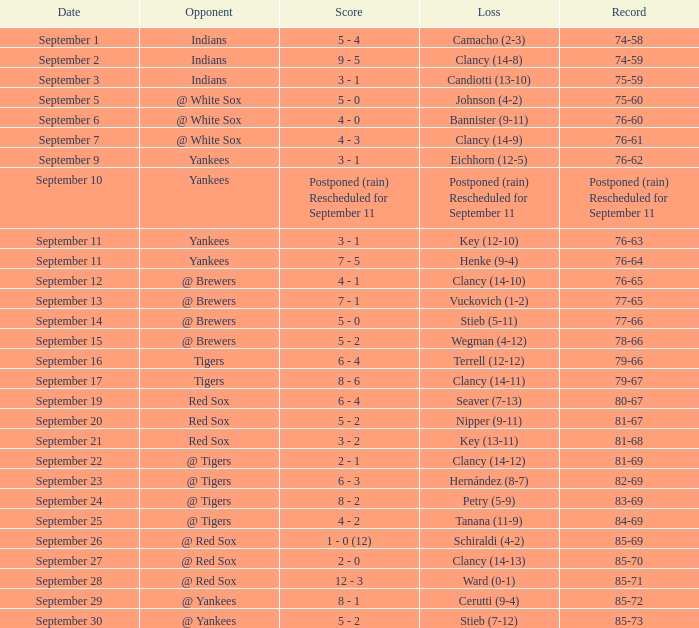Who was the blue jays' adversary when their record was 84-69? @ Tigers. Parse the full table. {'header': ['Date', 'Opponent', 'Score', 'Loss', 'Record'], 'rows': [['September 1', 'Indians', '5 - 4', 'Camacho (2-3)', '74-58'], ['September 2', 'Indians', '9 - 5', 'Clancy (14-8)', '74-59'], ['September 3', 'Indians', '3 - 1', 'Candiotti (13-10)', '75-59'], ['September 5', '@ White Sox', '5 - 0', 'Johnson (4-2)', '75-60'], ['September 6', '@ White Sox', '4 - 0', 'Bannister (9-11)', '76-60'], ['September 7', '@ White Sox', '4 - 3', 'Clancy (14-9)', '76-61'], ['September 9', 'Yankees', '3 - 1', 'Eichhorn (12-5)', '76-62'], ['September 10', 'Yankees', 'Postponed (rain) Rescheduled for September 11', 'Postponed (rain) Rescheduled for September 11', 'Postponed (rain) Rescheduled for September 11'], ['September 11', 'Yankees', '3 - 1', 'Key (12-10)', '76-63'], ['September 11', 'Yankees', '7 - 5', 'Henke (9-4)', '76-64'], ['September 12', '@ Brewers', '4 - 1', 'Clancy (14-10)', '76-65'], ['September 13', '@ Brewers', '7 - 1', 'Vuckovich (1-2)', '77-65'], ['September 14', '@ Brewers', '5 - 0', 'Stieb (5-11)', '77-66'], ['September 15', '@ Brewers', '5 - 2', 'Wegman (4-12)', '78-66'], ['September 16', 'Tigers', '6 - 4', 'Terrell (12-12)', '79-66'], ['September 17', 'Tigers', '8 - 6', 'Clancy (14-11)', '79-67'], ['September 19', 'Red Sox', '6 - 4', 'Seaver (7-13)', '80-67'], ['September 20', 'Red Sox', '5 - 2', 'Nipper (9-11)', '81-67'], ['September 21', 'Red Sox', '3 - 2', 'Key (13-11)', '81-68'], ['September 22', '@ Tigers', '2 - 1', 'Clancy (14-12)', '81-69'], ['September 23', '@ Tigers', '6 - 3', 'Hernández (8-7)', '82-69'], ['September 24', '@ Tigers', '8 - 2', 'Petry (5-9)', '83-69'], ['September 25', '@ Tigers', '4 - 2', 'Tanana (11-9)', '84-69'], ['September 26', '@ Red Sox', '1 - 0 (12)', 'Schiraldi (4-2)', '85-69'], ['September 27', '@ Red Sox', '2 - 0', 'Clancy (14-13)', '85-70'], ['September 28', '@ Red Sox', '12 - 3', 'Ward (0-1)', '85-71'], ['September 29', '@ Yankees', '8 - 1', 'Cerutti (9-4)', '85-72'], ['September 30', '@ Yankees', '5 - 2', 'Stieb (7-12)', '85-73']]} 